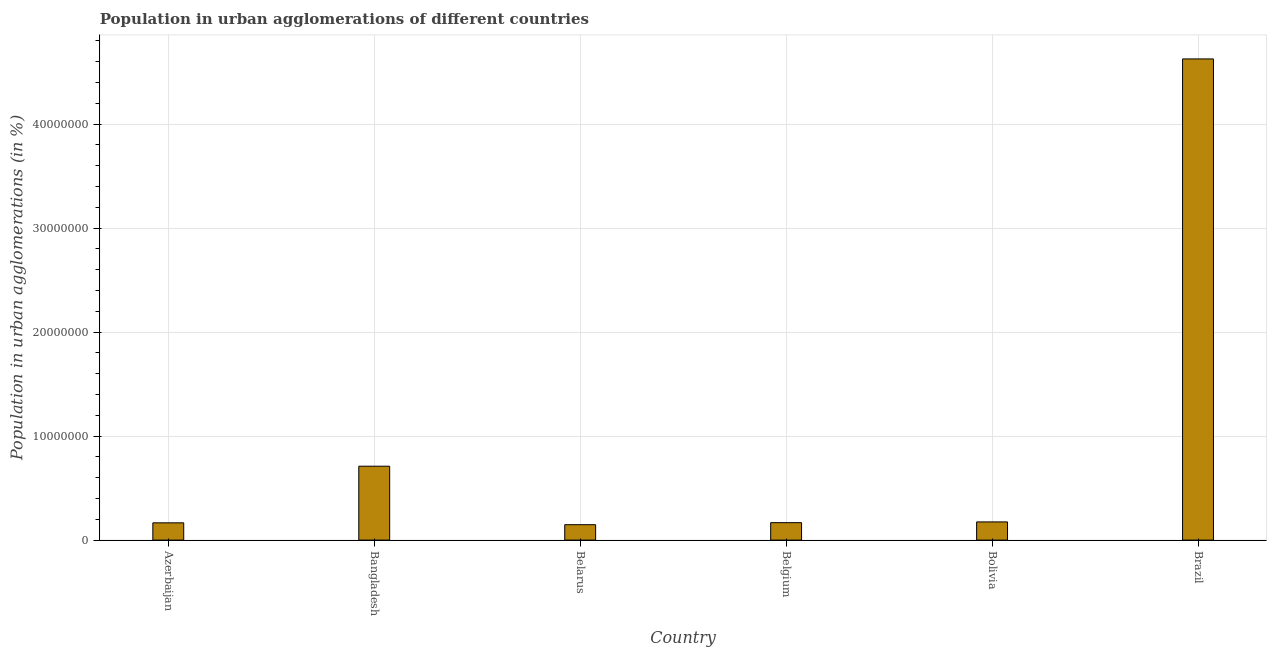Does the graph contain any zero values?
Offer a terse response. No. What is the title of the graph?
Offer a terse response. Population in urban agglomerations of different countries. What is the label or title of the X-axis?
Offer a terse response. Country. What is the label or title of the Y-axis?
Offer a terse response. Population in urban agglomerations (in %). What is the population in urban agglomerations in Belgium?
Offer a terse response. 1.68e+06. Across all countries, what is the maximum population in urban agglomerations?
Keep it short and to the point. 4.63e+07. Across all countries, what is the minimum population in urban agglomerations?
Give a very brief answer. 1.48e+06. In which country was the population in urban agglomerations minimum?
Your response must be concise. Belarus. What is the sum of the population in urban agglomerations?
Your response must be concise. 5.99e+07. What is the difference between the population in urban agglomerations in Belarus and Belgium?
Offer a terse response. -1.95e+05. What is the average population in urban agglomerations per country?
Provide a short and direct response. 9.99e+06. What is the median population in urban agglomerations?
Your answer should be very brief. 1.71e+06. What is the ratio of the population in urban agglomerations in Azerbaijan to that in Belarus?
Provide a succinct answer. 1.12. What is the difference between the highest and the second highest population in urban agglomerations?
Offer a very short reply. 3.92e+07. Is the sum of the population in urban agglomerations in Azerbaijan and Belgium greater than the maximum population in urban agglomerations across all countries?
Your response must be concise. No. What is the difference between the highest and the lowest population in urban agglomerations?
Your response must be concise. 4.48e+07. How many countries are there in the graph?
Provide a short and direct response. 6. What is the difference between two consecutive major ticks on the Y-axis?
Provide a succinct answer. 1.00e+07. Are the values on the major ticks of Y-axis written in scientific E-notation?
Make the answer very short. No. What is the Population in urban agglomerations (in %) in Azerbaijan?
Ensure brevity in your answer.  1.66e+06. What is the Population in urban agglomerations (in %) in Bangladesh?
Your answer should be very brief. 7.10e+06. What is the Population in urban agglomerations (in %) of Belarus?
Offer a terse response. 1.48e+06. What is the Population in urban agglomerations (in %) in Belgium?
Provide a short and direct response. 1.68e+06. What is the Population in urban agglomerations (in %) in Bolivia?
Offer a very short reply. 1.75e+06. What is the Population in urban agglomerations (in %) in Brazil?
Your response must be concise. 4.63e+07. What is the difference between the Population in urban agglomerations (in %) in Azerbaijan and Bangladesh?
Provide a short and direct response. -5.44e+06. What is the difference between the Population in urban agglomerations (in %) in Azerbaijan and Belarus?
Your response must be concise. 1.79e+05. What is the difference between the Population in urban agglomerations (in %) in Azerbaijan and Belgium?
Give a very brief answer. -1.58e+04. What is the difference between the Population in urban agglomerations (in %) in Azerbaijan and Bolivia?
Offer a very short reply. -8.78e+04. What is the difference between the Population in urban agglomerations (in %) in Azerbaijan and Brazil?
Your answer should be compact. -4.46e+07. What is the difference between the Population in urban agglomerations (in %) in Bangladesh and Belarus?
Give a very brief answer. 5.62e+06. What is the difference between the Population in urban agglomerations (in %) in Bangladesh and Belgium?
Ensure brevity in your answer.  5.43e+06. What is the difference between the Population in urban agglomerations (in %) in Bangladesh and Bolivia?
Give a very brief answer. 5.36e+06. What is the difference between the Population in urban agglomerations (in %) in Bangladesh and Brazil?
Offer a terse response. -3.92e+07. What is the difference between the Population in urban agglomerations (in %) in Belarus and Belgium?
Give a very brief answer. -1.95e+05. What is the difference between the Population in urban agglomerations (in %) in Belarus and Bolivia?
Offer a terse response. -2.67e+05. What is the difference between the Population in urban agglomerations (in %) in Belarus and Brazil?
Your answer should be compact. -4.48e+07. What is the difference between the Population in urban agglomerations (in %) in Belgium and Bolivia?
Offer a very short reply. -7.21e+04. What is the difference between the Population in urban agglomerations (in %) in Belgium and Brazil?
Ensure brevity in your answer.  -4.46e+07. What is the difference between the Population in urban agglomerations (in %) in Bolivia and Brazil?
Ensure brevity in your answer.  -4.45e+07. What is the ratio of the Population in urban agglomerations (in %) in Azerbaijan to that in Bangladesh?
Ensure brevity in your answer.  0.23. What is the ratio of the Population in urban agglomerations (in %) in Azerbaijan to that in Belarus?
Your answer should be compact. 1.12. What is the ratio of the Population in urban agglomerations (in %) in Azerbaijan to that in Bolivia?
Offer a very short reply. 0.95. What is the ratio of the Population in urban agglomerations (in %) in Azerbaijan to that in Brazil?
Ensure brevity in your answer.  0.04. What is the ratio of the Population in urban agglomerations (in %) in Bangladesh to that in Belarus?
Your answer should be compact. 4.8. What is the ratio of the Population in urban agglomerations (in %) in Bangladesh to that in Belgium?
Your response must be concise. 4.24. What is the ratio of the Population in urban agglomerations (in %) in Bangladesh to that in Bolivia?
Make the answer very short. 4.06. What is the ratio of the Population in urban agglomerations (in %) in Bangladesh to that in Brazil?
Keep it short and to the point. 0.15. What is the ratio of the Population in urban agglomerations (in %) in Belarus to that in Belgium?
Make the answer very short. 0.88. What is the ratio of the Population in urban agglomerations (in %) in Belarus to that in Bolivia?
Your response must be concise. 0.85. What is the ratio of the Population in urban agglomerations (in %) in Belarus to that in Brazil?
Your answer should be very brief. 0.03. What is the ratio of the Population in urban agglomerations (in %) in Belgium to that in Brazil?
Your response must be concise. 0.04. What is the ratio of the Population in urban agglomerations (in %) in Bolivia to that in Brazil?
Provide a succinct answer. 0.04. 